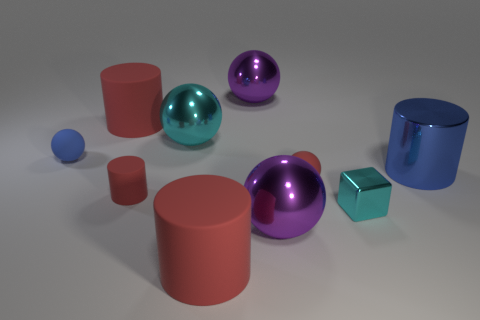There is a small ball that is the same color as the shiny cylinder; what is its material?
Offer a terse response. Rubber. There is a shiny sphere that is the same color as the shiny cube; what is its size?
Keep it short and to the point. Large. There is a metallic thing that is the same color as the block; what is its shape?
Offer a very short reply. Sphere. Is there anything else that has the same shape as the tiny cyan metallic object?
Provide a succinct answer. No. Are there an equal number of red matte things to the left of the big blue object and cylinders?
Keep it short and to the point. Yes. What number of matte cylinders are both in front of the big cyan shiny ball and on the left side of the large cyan metallic ball?
Offer a very short reply. 1. There is a cyan metallic object that is the same shape as the tiny blue object; what is its size?
Make the answer very short. Large. How many blue things have the same material as the tiny red sphere?
Keep it short and to the point. 1. Are there fewer matte things that are in front of the small cylinder than blue objects?
Your answer should be compact. Yes. How many cyan metallic blocks are there?
Your response must be concise. 1. 